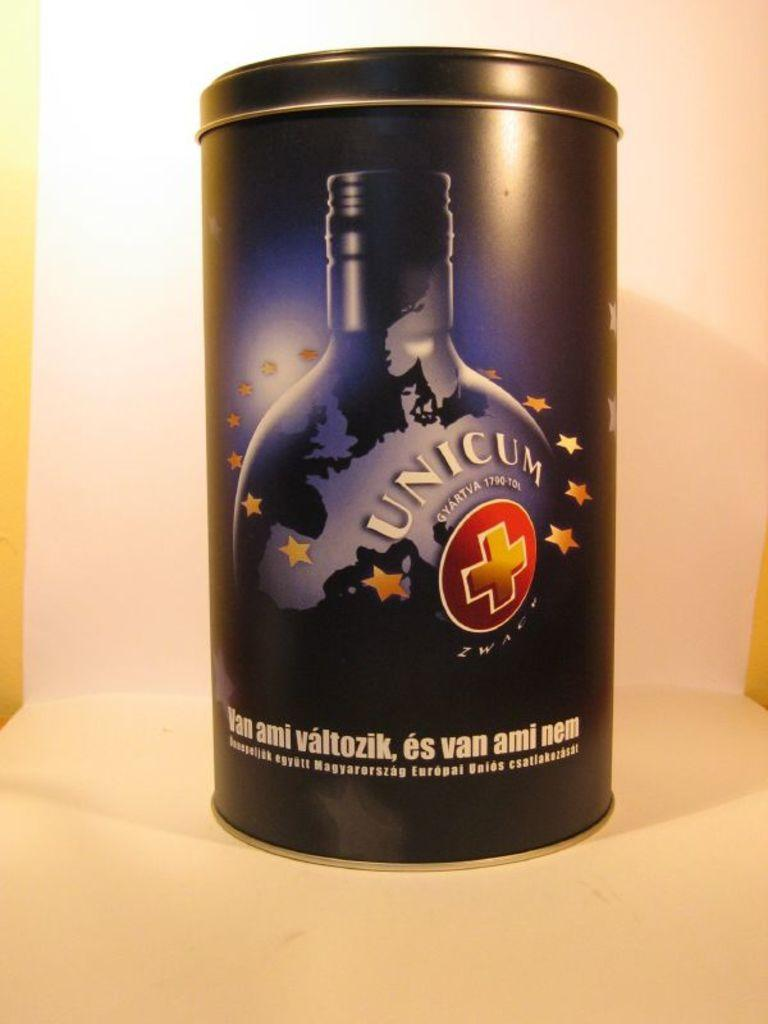Provide a one-sentence caption for the provided image. The metal Unicum liquer container has the stars of the European Union surrounding the image of the bottle. 